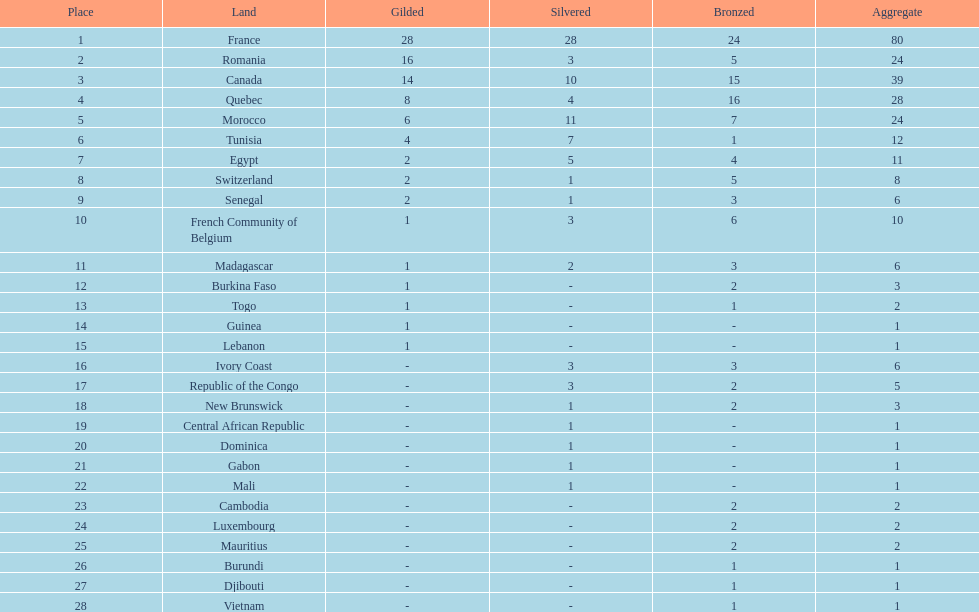How many nations won at least 10 medals? 8. 